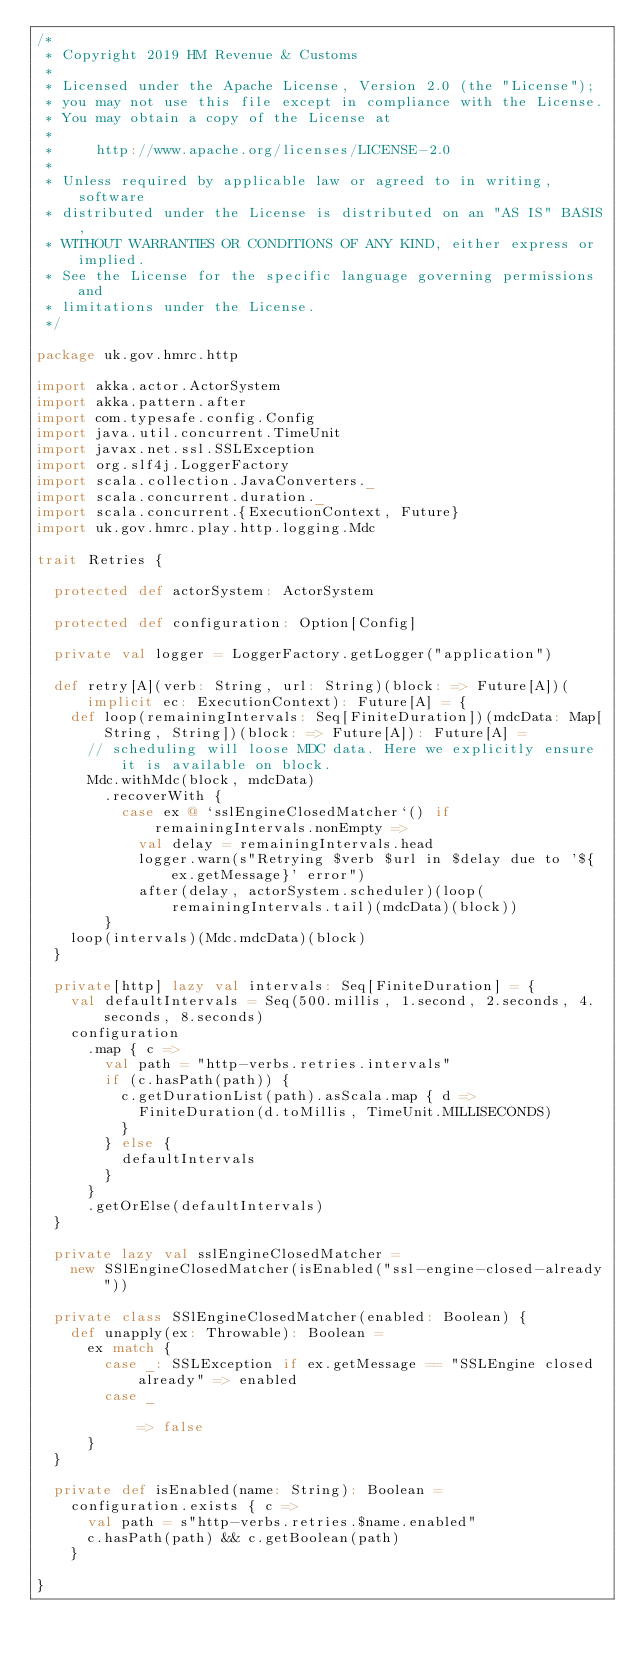Convert code to text. <code><loc_0><loc_0><loc_500><loc_500><_Scala_>/*
 * Copyright 2019 HM Revenue & Customs
 *
 * Licensed under the Apache License, Version 2.0 (the "License");
 * you may not use this file except in compliance with the License.
 * You may obtain a copy of the License at
 *
 *     http://www.apache.org/licenses/LICENSE-2.0
 *
 * Unless required by applicable law or agreed to in writing, software
 * distributed under the License is distributed on an "AS IS" BASIS,
 * WITHOUT WARRANTIES OR CONDITIONS OF ANY KIND, either express or implied.
 * See the License for the specific language governing permissions and
 * limitations under the License.
 */

package uk.gov.hmrc.http

import akka.actor.ActorSystem
import akka.pattern.after
import com.typesafe.config.Config
import java.util.concurrent.TimeUnit
import javax.net.ssl.SSLException
import org.slf4j.LoggerFactory
import scala.collection.JavaConverters._
import scala.concurrent.duration._
import scala.concurrent.{ExecutionContext, Future}
import uk.gov.hmrc.play.http.logging.Mdc

trait Retries {

  protected def actorSystem: ActorSystem

  protected def configuration: Option[Config]

  private val logger = LoggerFactory.getLogger("application")

  def retry[A](verb: String, url: String)(block: => Future[A])(implicit ec: ExecutionContext): Future[A] = {
    def loop(remainingIntervals: Seq[FiniteDuration])(mdcData: Map[String, String])(block: => Future[A]): Future[A] =
      // scheduling will loose MDC data. Here we explicitly ensure it is available on block.
      Mdc.withMdc(block, mdcData)
        .recoverWith {
          case ex @ `sslEngineClosedMatcher`() if remainingIntervals.nonEmpty =>
            val delay = remainingIntervals.head
            logger.warn(s"Retrying $verb $url in $delay due to '${ex.getMessage}' error")
            after(delay, actorSystem.scheduler)(loop(remainingIntervals.tail)(mdcData)(block))
        }
    loop(intervals)(Mdc.mdcData)(block)
  }

  private[http] lazy val intervals: Seq[FiniteDuration] = {
    val defaultIntervals = Seq(500.millis, 1.second, 2.seconds, 4.seconds, 8.seconds)
    configuration
      .map { c =>
        val path = "http-verbs.retries.intervals"
        if (c.hasPath(path)) {
          c.getDurationList(path).asScala.map { d =>
            FiniteDuration(d.toMillis, TimeUnit.MILLISECONDS)
          }
        } else {
          defaultIntervals
        }
      }
      .getOrElse(defaultIntervals)
  }

  private lazy val sslEngineClosedMatcher =
    new SSlEngineClosedMatcher(isEnabled("ssl-engine-closed-already"))

  private class SSlEngineClosedMatcher(enabled: Boolean) {
    def unapply(ex: Throwable): Boolean =
      ex match {
        case _: SSLException if ex.getMessage == "SSLEngine closed already" => enabled
        case _                                                              => false
      }
  }

  private def isEnabled(name: String): Boolean =
    configuration.exists { c =>
      val path = s"http-verbs.retries.$name.enabled"
      c.hasPath(path) && c.getBoolean(path)
    }

}
</code> 